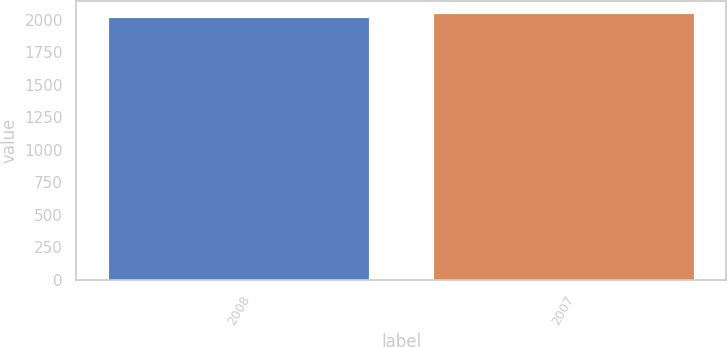Convert chart. <chart><loc_0><loc_0><loc_500><loc_500><bar_chart><fcel>2008<fcel>2007<nl><fcel>2013.3<fcel>2044.8<nl></chart> 